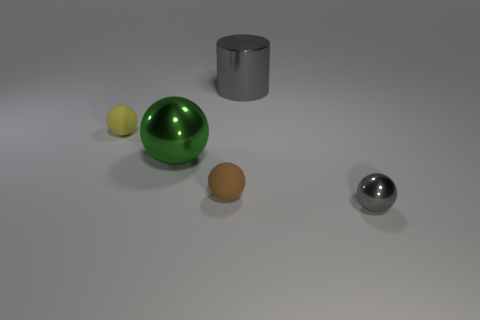Add 2 big spheres. How many objects exist? 7 Subtract all red spheres. Subtract all brown cylinders. How many spheres are left? 4 Subtract all cylinders. How many objects are left? 4 Add 5 cylinders. How many cylinders are left? 6 Add 5 big cylinders. How many big cylinders exist? 6 Subtract 0 purple blocks. How many objects are left? 5 Subtract all big cylinders. Subtract all tiny balls. How many objects are left? 1 